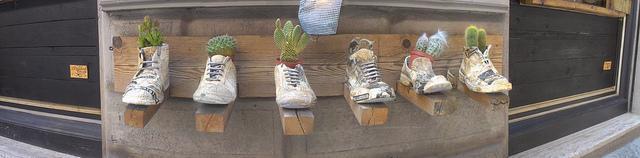How many shoes are displayed?
Give a very brief answer. 6. 